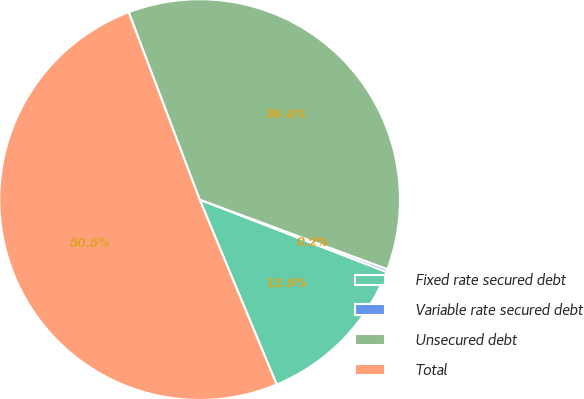Convert chart. <chart><loc_0><loc_0><loc_500><loc_500><pie_chart><fcel>Fixed rate secured debt<fcel>Variable rate secured debt<fcel>Unsecured debt<fcel>Total<nl><fcel>12.84%<fcel>0.23%<fcel>36.41%<fcel>50.52%<nl></chart> 